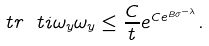<formula> <loc_0><loc_0><loc_500><loc_500>\ t r { \ t i { \omega } _ { y } } { \omega _ { y } } \leq \frac { C } { t } e ^ { C e ^ { B \sigma ^ { - \lambda } } } .</formula> 